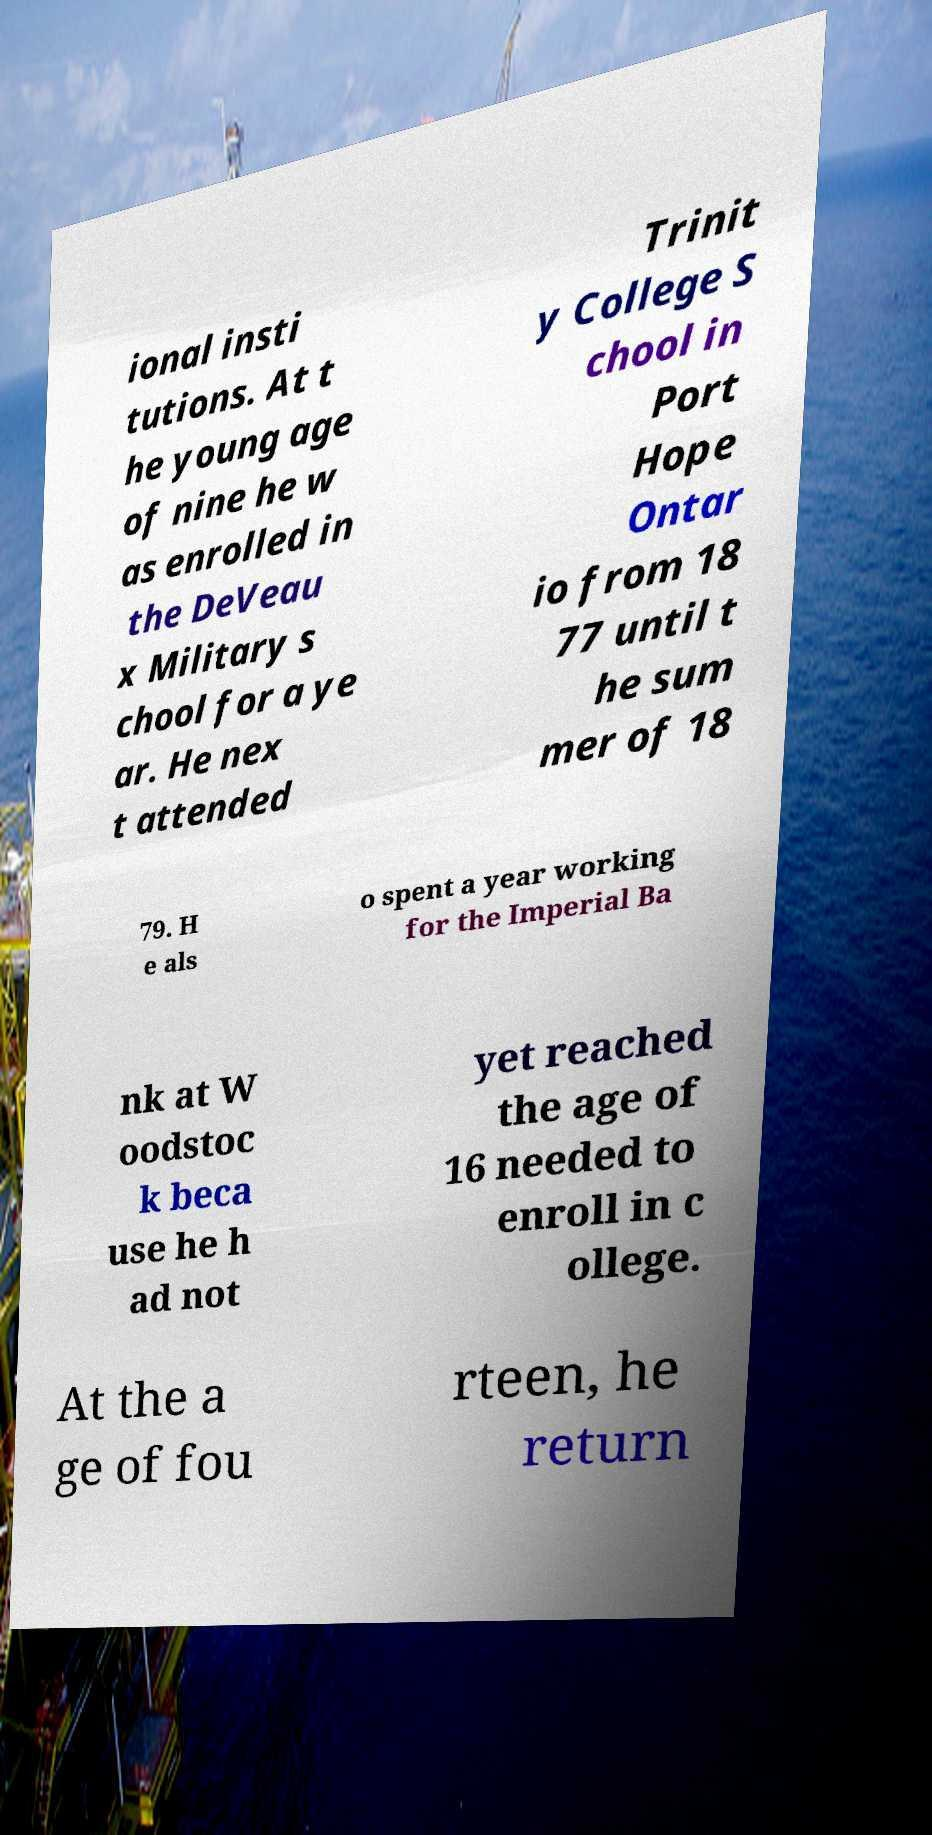Can you accurately transcribe the text from the provided image for me? ional insti tutions. At t he young age of nine he w as enrolled in the DeVeau x Military s chool for a ye ar. He nex t attended Trinit y College S chool in Port Hope Ontar io from 18 77 until t he sum mer of 18 79. H e als o spent a year working for the Imperial Ba nk at W oodstoc k beca use he h ad not yet reached the age of 16 needed to enroll in c ollege. At the a ge of fou rteen, he return 